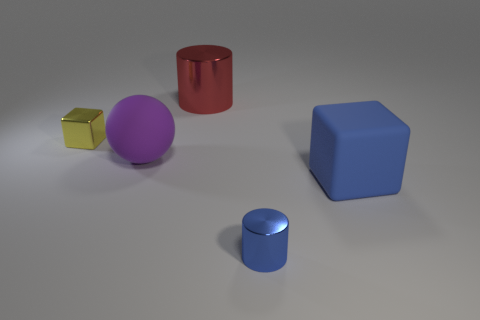Does the tiny metal thing in front of the blue cube have the same color as the big metal cylinder?
Provide a short and direct response. No. What material is the small object in front of the cube that is on the right side of the metal thing that is behind the tiny yellow metal object?
Make the answer very short. Metal. Does the yellow object have the same size as the matte sphere?
Ensure brevity in your answer.  No. There is a big matte block; is its color the same as the tiny metallic thing that is to the right of the big purple object?
Keep it short and to the point. Yes. There is a big object that is made of the same material as the tiny yellow thing; what is its shape?
Your answer should be very brief. Cylinder. Is the shape of the tiny metal thing behind the small blue cylinder the same as  the small blue shiny object?
Your response must be concise. No. There is a metal cylinder that is in front of the cube on the left side of the big blue cube; how big is it?
Make the answer very short. Small. The small thing that is made of the same material as the tiny block is what color?
Keep it short and to the point. Blue. How many green shiny things have the same size as the blue shiny object?
Give a very brief answer. 0. What number of gray objects are shiny cylinders or tiny metallic blocks?
Give a very brief answer. 0. 